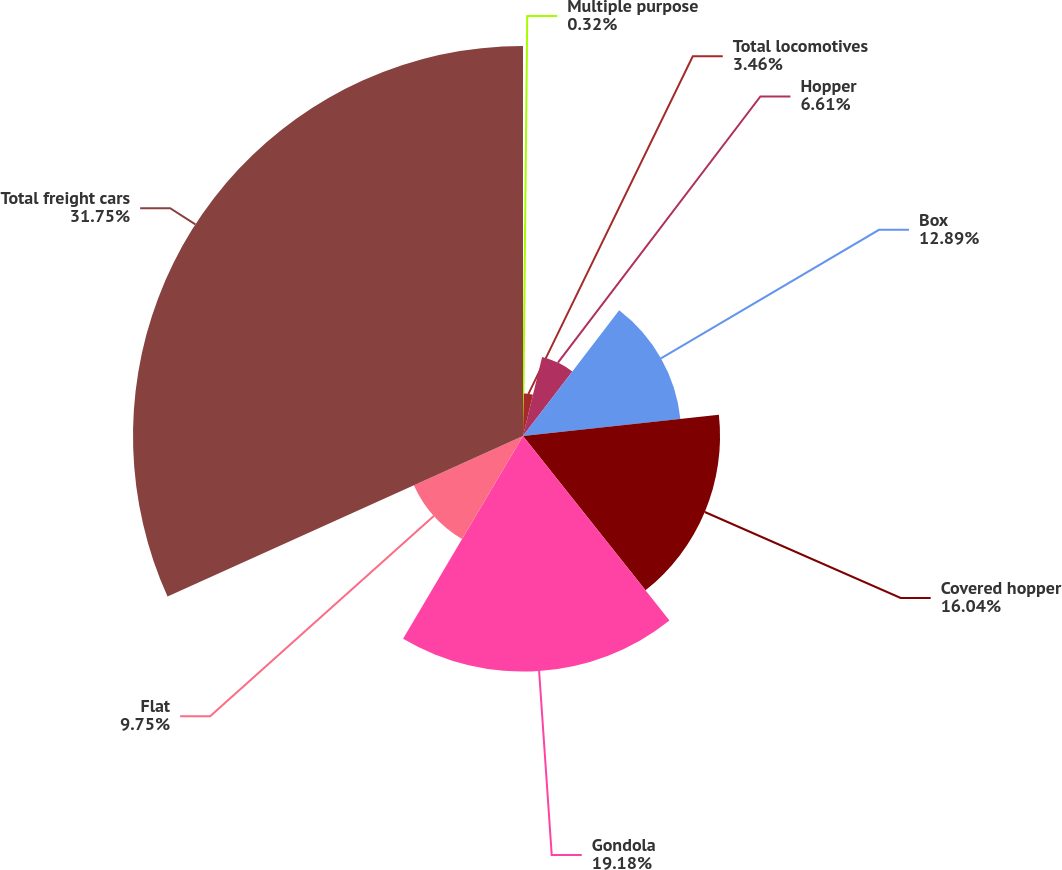<chart> <loc_0><loc_0><loc_500><loc_500><pie_chart><fcel>Multiple purpose<fcel>Total locomotives<fcel>Hopper<fcel>Box<fcel>Covered hopper<fcel>Gondola<fcel>Flat<fcel>Total freight cars<nl><fcel>0.32%<fcel>3.46%<fcel>6.61%<fcel>12.89%<fcel>16.04%<fcel>19.18%<fcel>9.75%<fcel>31.75%<nl></chart> 